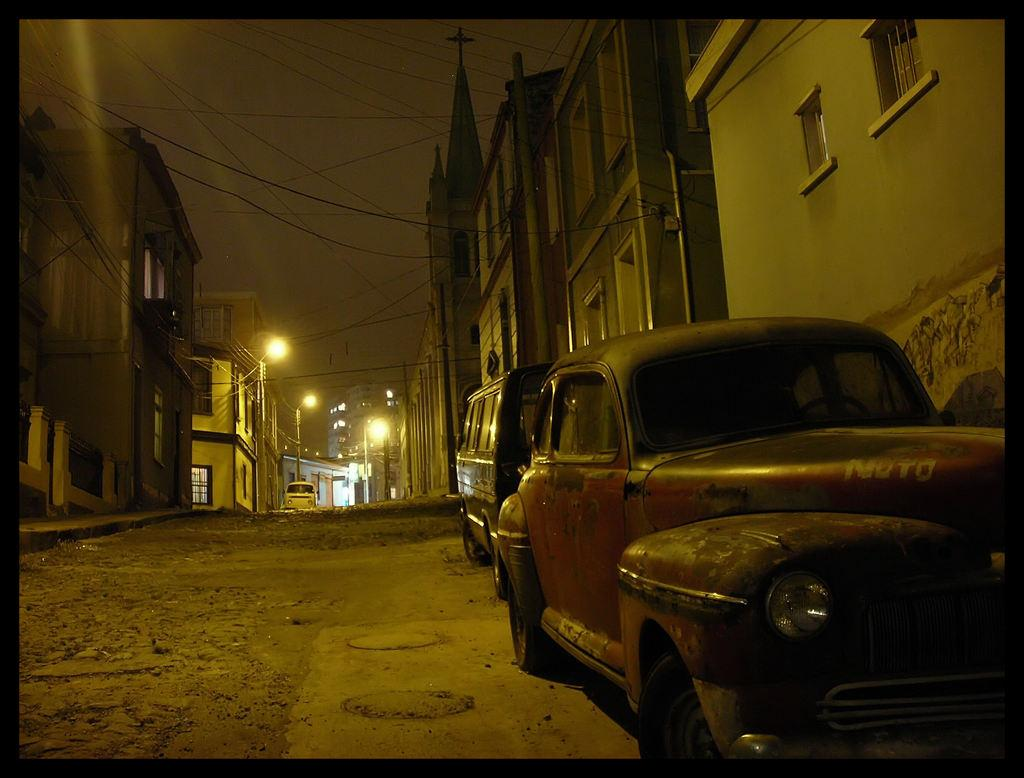What type of structures can be seen in the image? There are buildings in the image. What else is present in the image besides buildings? There are vehicles in the image. What can be seen in the background of the image? There are poles and lights in the background of the image. What is visible at the top of the image? The sky is visible at the top of the image, and there are wires visible as well. What type of butter is being served on the plate in the image? There is no butter or plate present in the image; it features buildings, vehicles, poles, lights, the sky, and wires. 